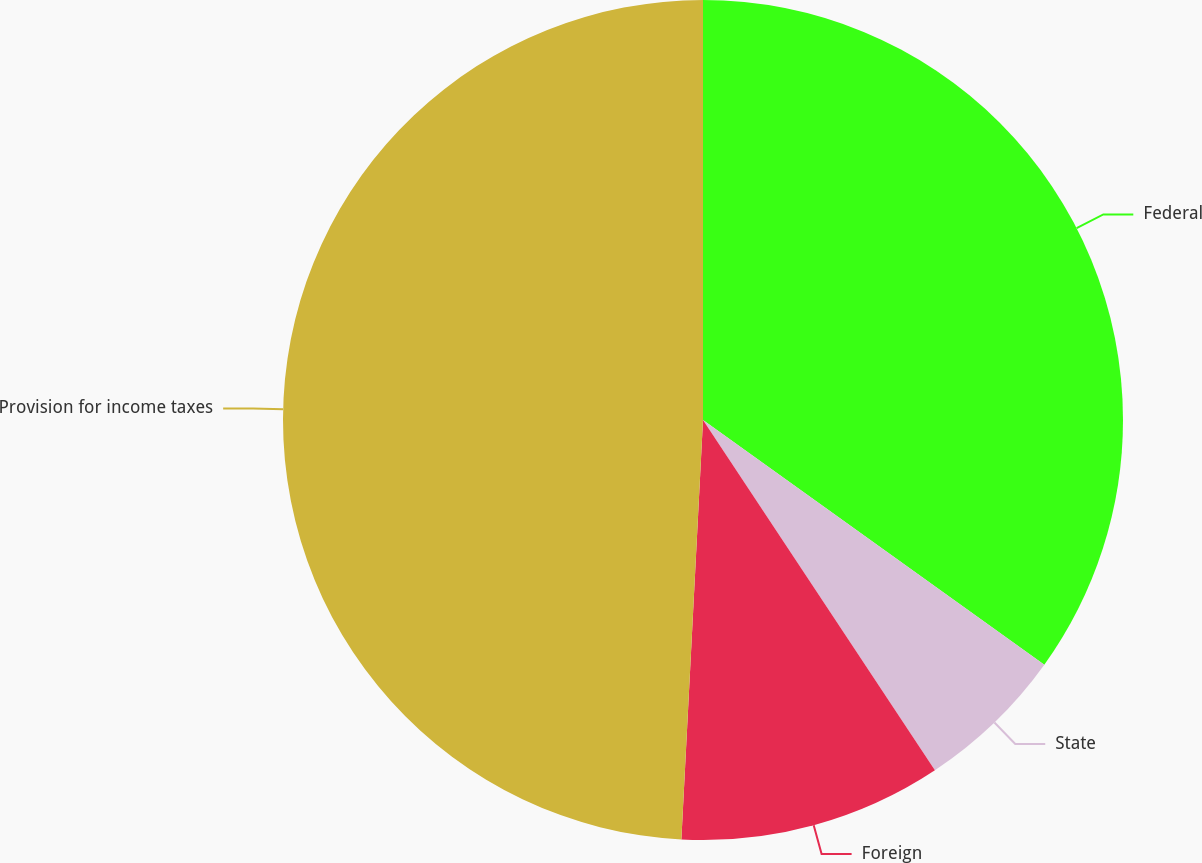Convert chart to OTSL. <chart><loc_0><loc_0><loc_500><loc_500><pie_chart><fcel>Federal<fcel>State<fcel>Foreign<fcel>Provision for income taxes<nl><fcel>34.9%<fcel>5.79%<fcel>10.13%<fcel>49.18%<nl></chart> 